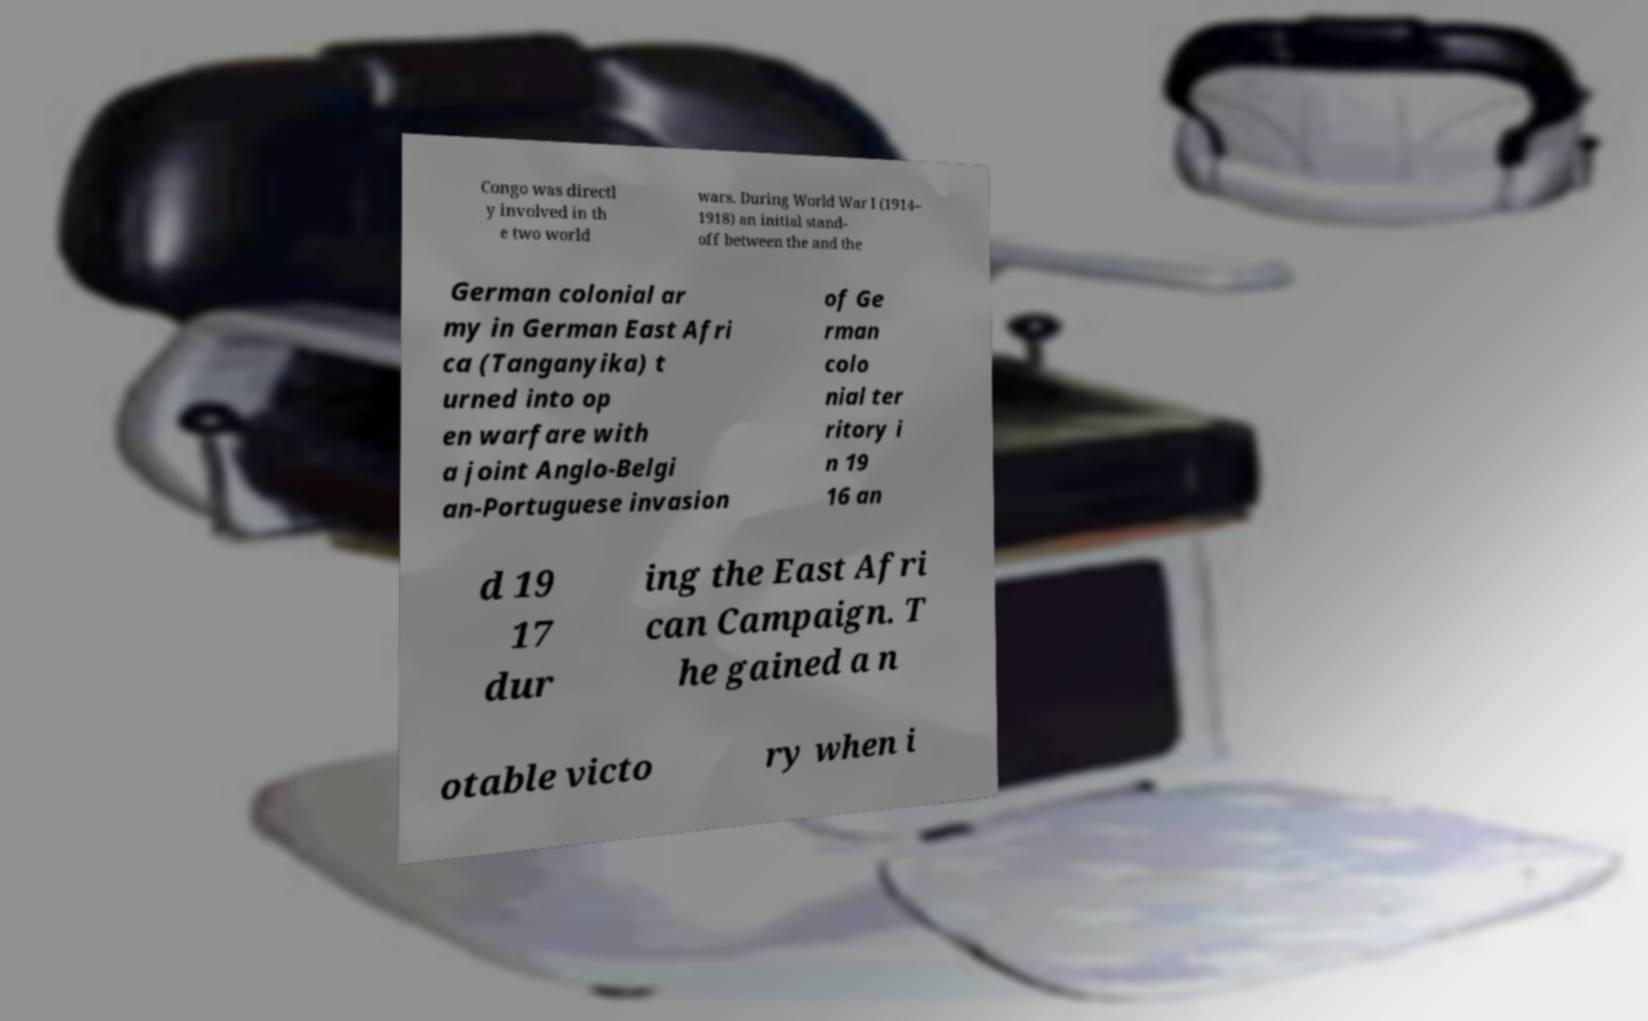There's text embedded in this image that I need extracted. Can you transcribe it verbatim? Congo was directl y involved in th e two world wars. During World War I (1914– 1918) an initial stand- off between the and the German colonial ar my in German East Afri ca (Tanganyika) t urned into op en warfare with a joint Anglo-Belgi an-Portuguese invasion of Ge rman colo nial ter ritory i n 19 16 an d 19 17 dur ing the East Afri can Campaign. T he gained a n otable victo ry when i 